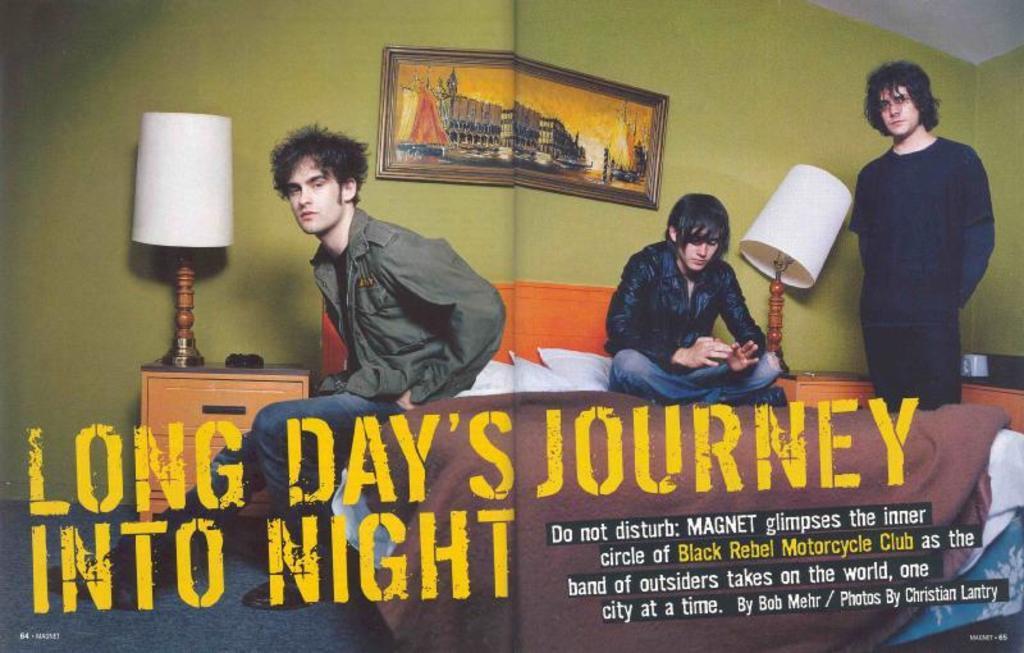Can you describe this image briefly? In this image we can see the picture of two men sitting on a bed. We can also see the lamps on the cupboards, a photo frame on a wall and a person standing. On the bottom of the image we can see some text. 